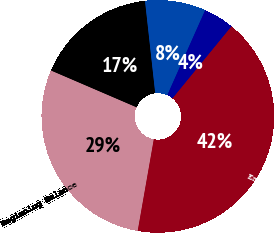<chart> <loc_0><loc_0><loc_500><loc_500><pie_chart><fcel>Beginning Balance<fcel>Increases related to tax<fcel>Decreases related to tax<fcel>Decreases related to<fcel>Ending Balance<nl><fcel>28.7%<fcel>16.78%<fcel>8.43%<fcel>4.25%<fcel>41.85%<nl></chart> 